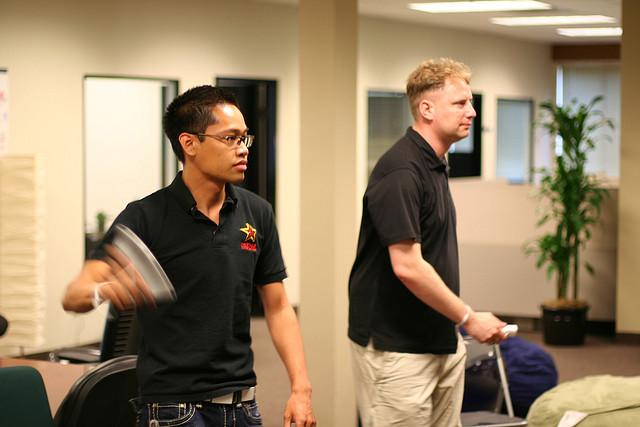What activity are the men involved in?

Choices:
A) gaming
B) gambling
C) sports
D) writing gaming 